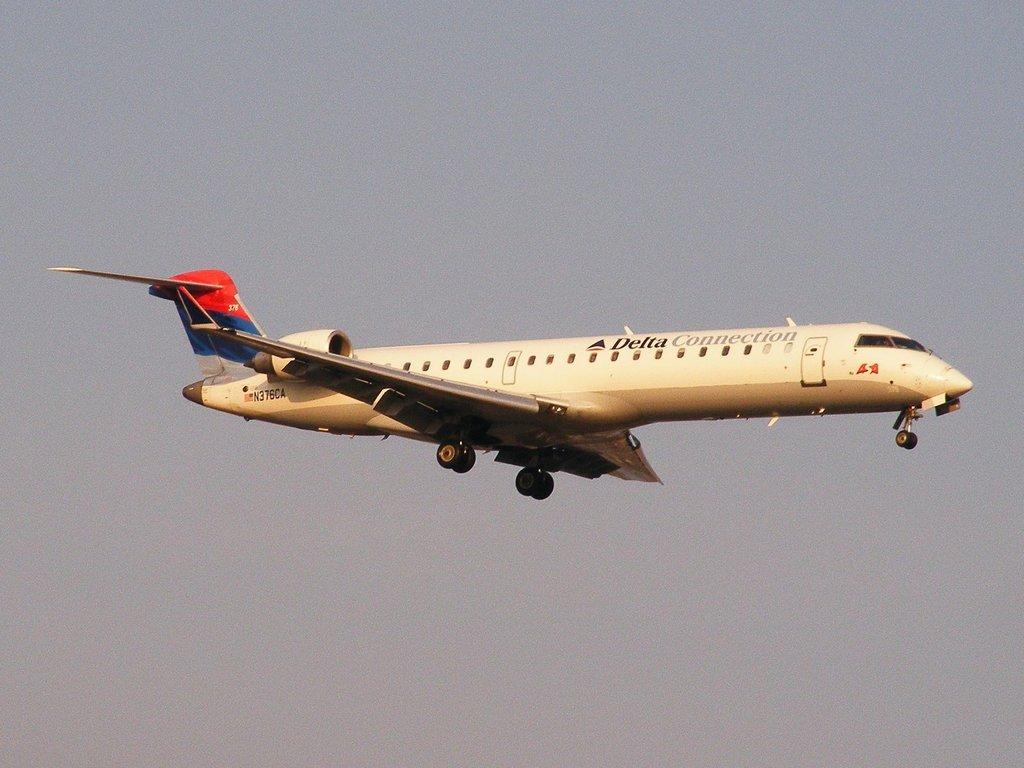What airline is this?
Give a very brief answer. Delta. 